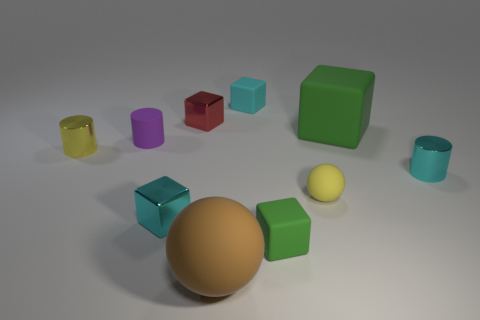What number of cubes are either tiny blue rubber things or small yellow things?
Make the answer very short. 0. The small matte cylinder is what color?
Keep it short and to the point. Purple. Does the rubber sphere behind the large sphere have the same size as the cyan metallic object in front of the yellow rubber sphere?
Offer a very short reply. Yes. Is the number of tiny yellow rubber things less than the number of tiny rubber cubes?
Make the answer very short. Yes. How many tiny rubber cubes are in front of the purple matte cylinder?
Your answer should be very brief. 1. What material is the large green thing?
Offer a very short reply. Rubber. Does the rubber cylinder have the same color as the big sphere?
Your answer should be very brief. No. Is the number of big green rubber things behind the small green block less than the number of tiny metallic blocks?
Your response must be concise. Yes. The tiny shiny cylinder that is on the right side of the brown rubber ball is what color?
Keep it short and to the point. Cyan. What is the shape of the cyan matte object?
Make the answer very short. Cube. 